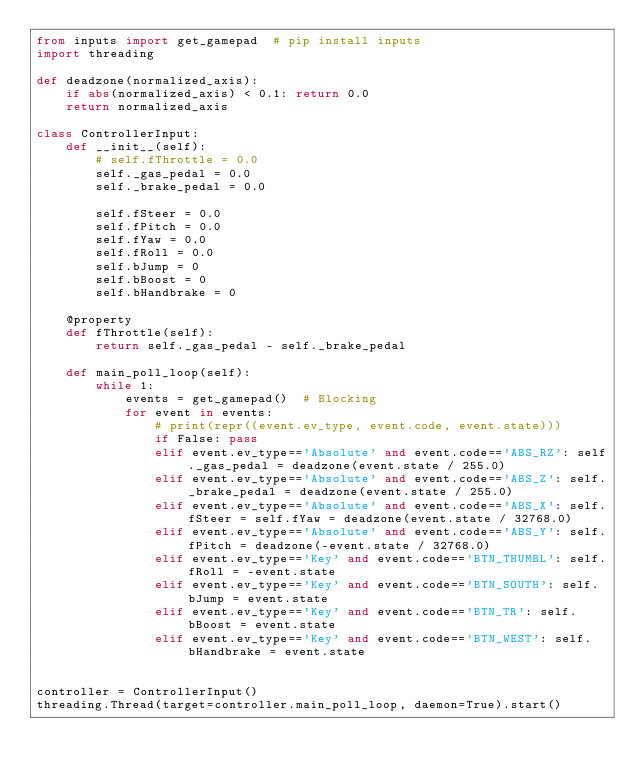Convert code to text. <code><loc_0><loc_0><loc_500><loc_500><_Python_>from inputs import get_gamepad  # pip install inputs
import threading

def deadzone(normalized_axis):
    if abs(normalized_axis) < 0.1: return 0.0
    return normalized_axis

class ControllerInput:
    def __init__(self):
        # self.fThrottle = 0.0
        self._gas_pedal = 0.0
        self._brake_pedal = 0.0

        self.fSteer = 0.0
        self.fPitch = 0.0
        self.fYaw = 0.0
        self.fRoll = 0.0
        self.bJump = 0
        self.bBoost = 0
        self.bHandbrake = 0

    @property
    def fThrottle(self):
        return self._gas_pedal - self._brake_pedal

    def main_poll_loop(self):
        while 1:
            events = get_gamepad()  # Blocking
            for event in events:
                # print(repr((event.ev_type, event.code, event.state)))
                if False: pass
                elif event.ev_type=='Absolute' and event.code=='ABS_RZ': self._gas_pedal = deadzone(event.state / 255.0)
                elif event.ev_type=='Absolute' and event.code=='ABS_Z': self._brake_pedal = deadzone(event.state / 255.0)
                elif event.ev_type=='Absolute' and event.code=='ABS_X': self.fSteer = self.fYaw = deadzone(event.state / 32768.0)
                elif event.ev_type=='Absolute' and event.code=='ABS_Y': self.fPitch = deadzone(-event.state / 32768.0)
                elif event.ev_type=='Key' and event.code=='BTN_THUMBL': self.fRoll = -event.state
                elif event.ev_type=='Key' and event.code=='BTN_SOUTH': self.bJump = event.state
                elif event.ev_type=='Key' and event.code=='BTN_TR': self.bBoost = event.state
                elif event.ev_type=='Key' and event.code=='BTN_WEST': self.bHandbrake = event.state


controller = ControllerInput()
threading.Thread(target=controller.main_poll_loop, daemon=True).start()
</code> 